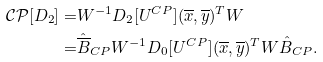Convert formula to latex. <formula><loc_0><loc_0><loc_500><loc_500>\mathcal { C P } [ D _ { 2 } ] = & W ^ { - 1 } D _ { 2 } [ U ^ { C P } ] ( \overline { x } , \overline { y } ) ^ { T } W \\ = & \hat { \overline { B } } _ { C P } W ^ { - 1 } D _ { 0 } [ U ^ { C P } ] ( \overline { x } , \overline { y } ) ^ { T } W \hat { B } _ { C P } .</formula> 